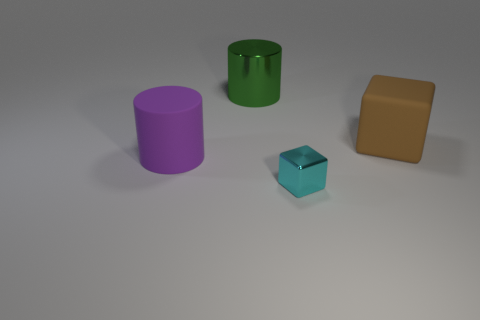How many small objects are brown matte blocks or gray matte cylinders?
Your answer should be compact. 0. Are there the same number of large blocks that are to the left of the big matte block and big gray metallic cylinders?
Ensure brevity in your answer.  Yes. There is a object right of the small cyan shiny cube; are there any rubber cubes on the left side of it?
Your answer should be compact. No. The shiny block has what color?
Provide a short and direct response. Cyan. What is the size of the object that is on the left side of the tiny cyan metal object and in front of the green thing?
Offer a very short reply. Large. What number of things are either cubes in front of the brown rubber block or gray shiny blocks?
Give a very brief answer. 1. What is the shape of the large brown thing that is made of the same material as the purple object?
Ensure brevity in your answer.  Cube. What shape is the cyan metal thing?
Give a very brief answer. Cube. There is a thing that is both to the left of the big brown matte thing and on the right side of the green object; what is its color?
Provide a succinct answer. Cyan. What is the shape of the other rubber object that is the same size as the purple matte thing?
Provide a succinct answer. Cube. 